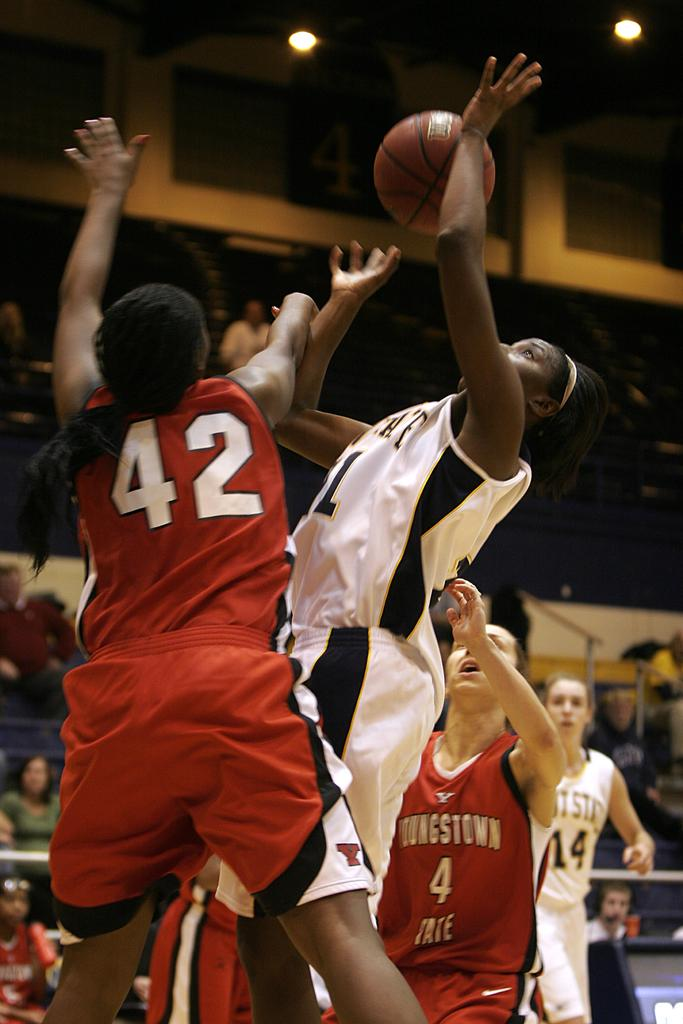What activity are the people in the image participating in? The people in the image are playing basketball. Are there any spectators in the image? Yes, there are people watching the game as an audience. Where is the throne located in the image? There is no throne present in the image. What type of music can be heard in the background of the image? There is no music present in the image, as it focuses on a basketball game. 